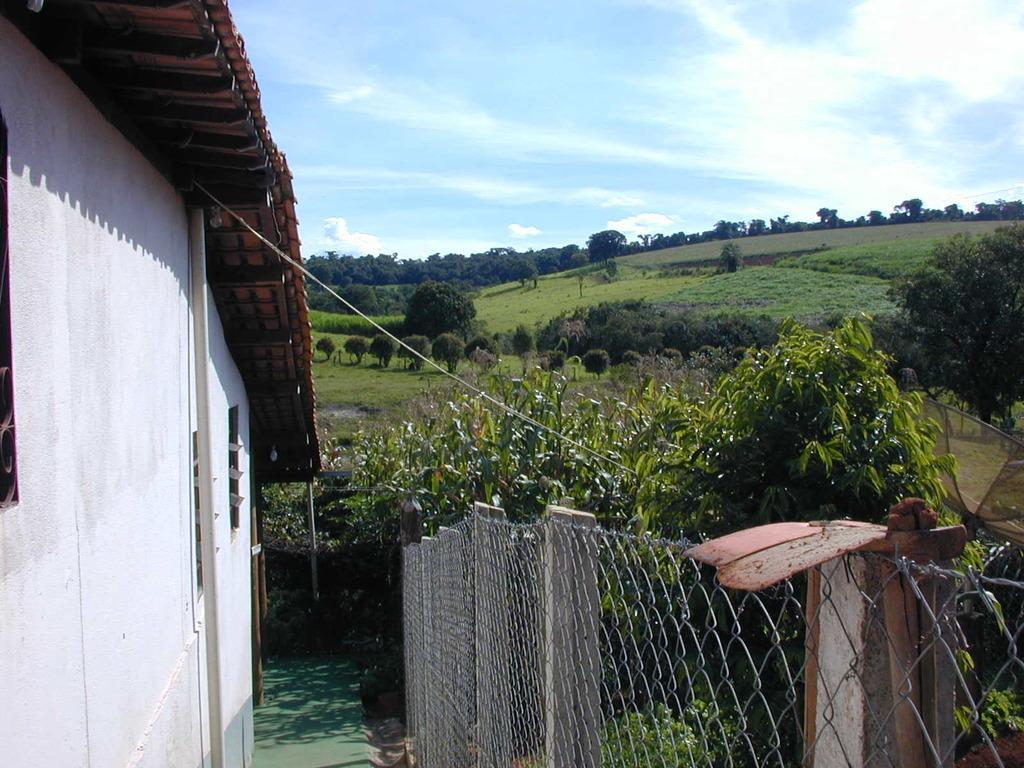Describe this image in one or two sentences. In the foreground of this image, there is a fencing and plants on the right. On the left, there is a building. In the background, there are trees, grass, sky and the cloud. 